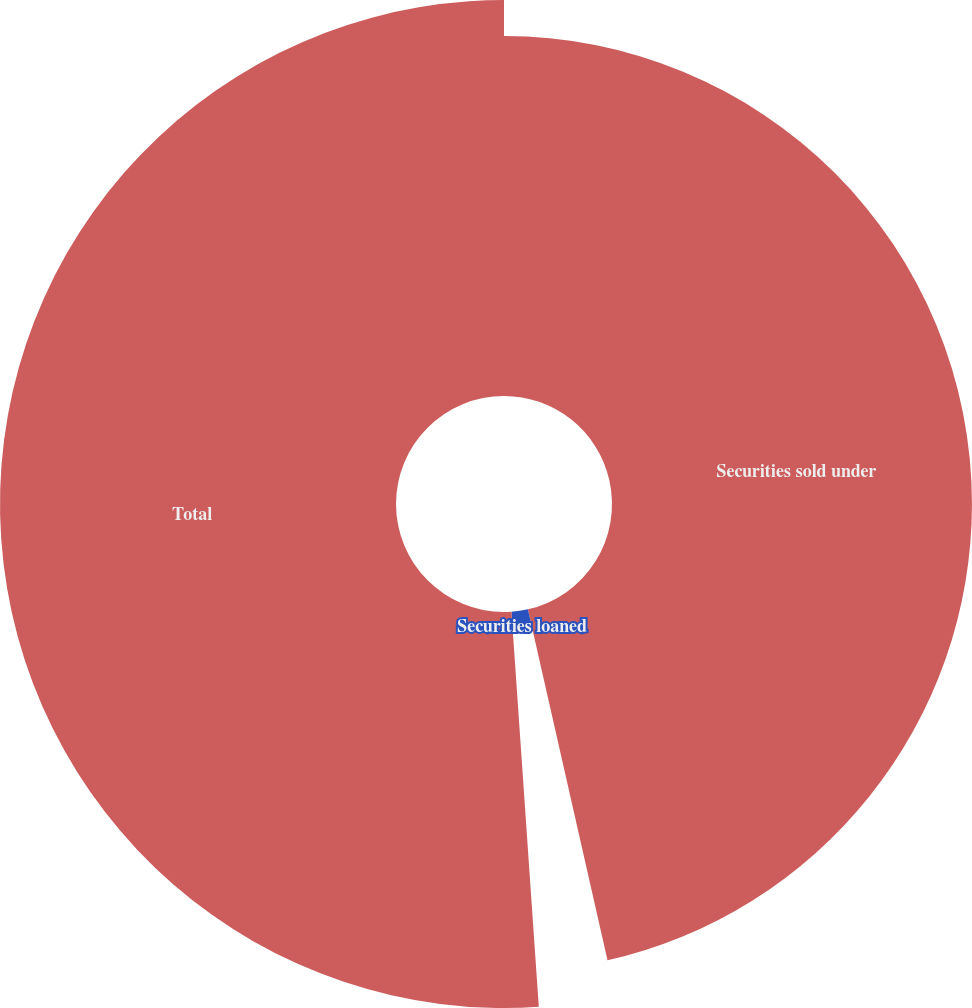<chart> <loc_0><loc_0><loc_500><loc_500><pie_chart><fcel>Securities sold under<fcel>Securities loaned<fcel>Total<nl><fcel>46.45%<fcel>2.45%<fcel>51.1%<nl></chart> 